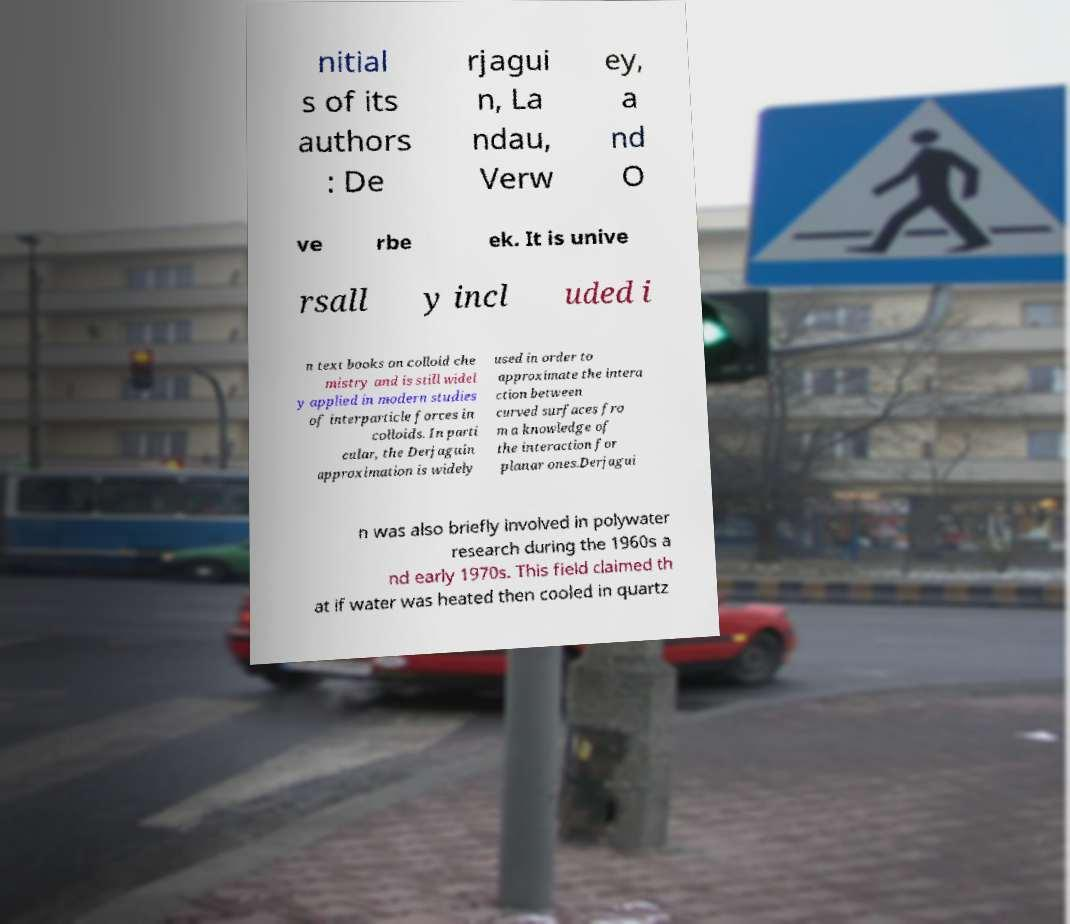I need the written content from this picture converted into text. Can you do that? nitial s of its authors : De rjagui n, La ndau, Verw ey, a nd O ve rbe ek. It is unive rsall y incl uded i n text books on colloid che mistry and is still widel y applied in modern studies of interparticle forces in colloids. In parti cular, the Derjaguin approximation is widely used in order to approximate the intera ction between curved surfaces fro m a knowledge of the interaction for planar ones.Derjagui n was also briefly involved in polywater research during the 1960s a nd early 1970s. This field claimed th at if water was heated then cooled in quartz 